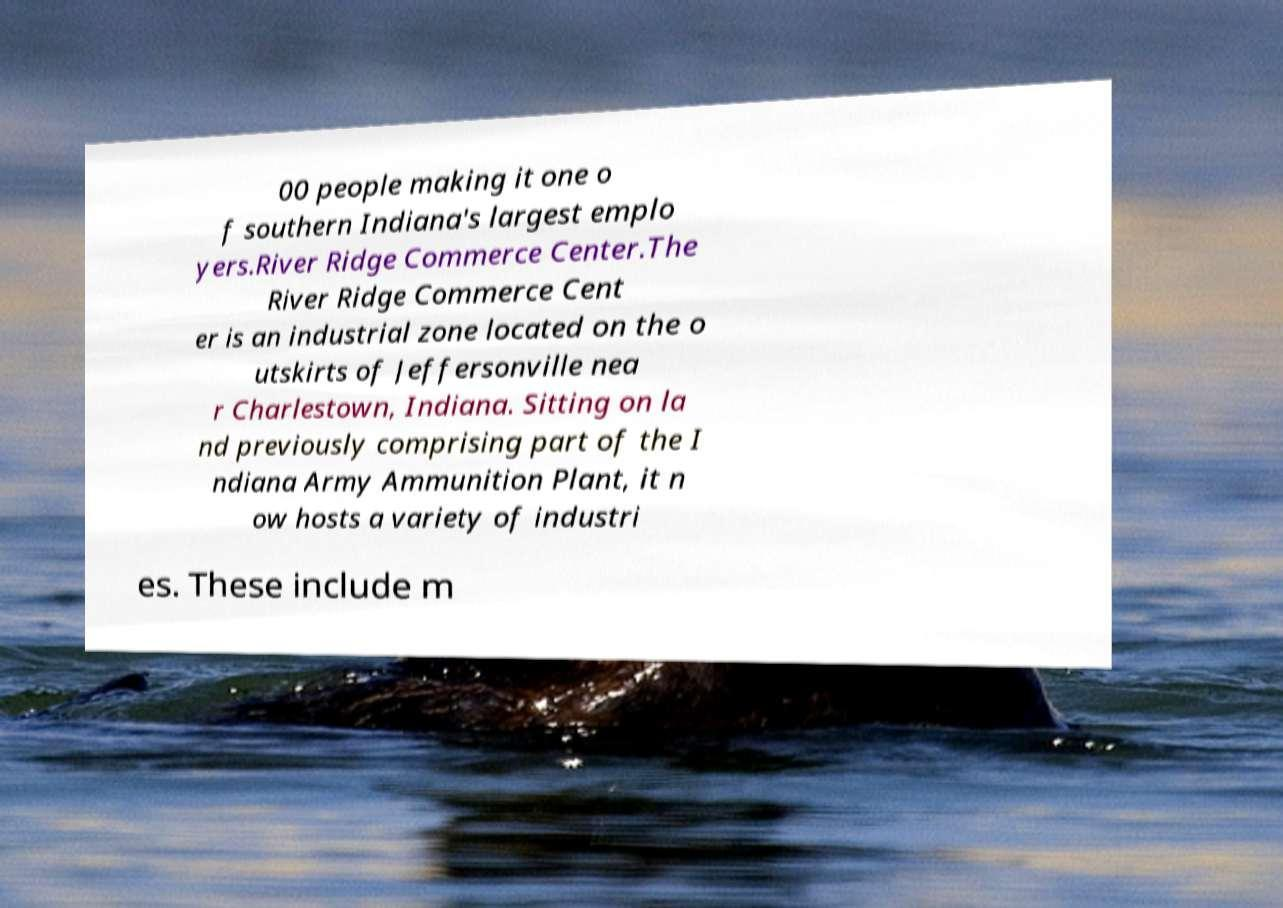What messages or text are displayed in this image? I need them in a readable, typed format. 00 people making it one o f southern Indiana's largest emplo yers.River Ridge Commerce Center.The River Ridge Commerce Cent er is an industrial zone located on the o utskirts of Jeffersonville nea r Charlestown, Indiana. Sitting on la nd previously comprising part of the I ndiana Army Ammunition Plant, it n ow hosts a variety of industri es. These include m 